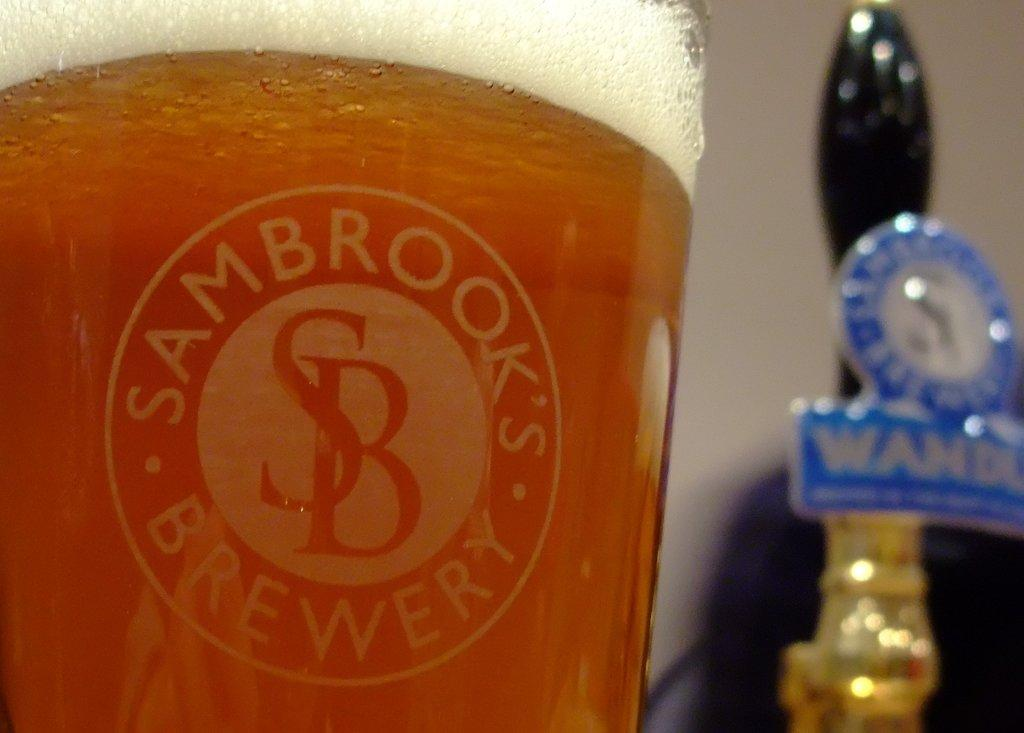<image>
Render a clear and concise summary of the photo. A full glass of beer with the logo for sambrook's brewery in its center. 